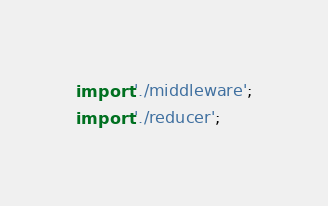Convert code to text. <code><loc_0><loc_0><loc_500><loc_500><_JavaScript_>import './middleware';
import './reducer';
</code> 